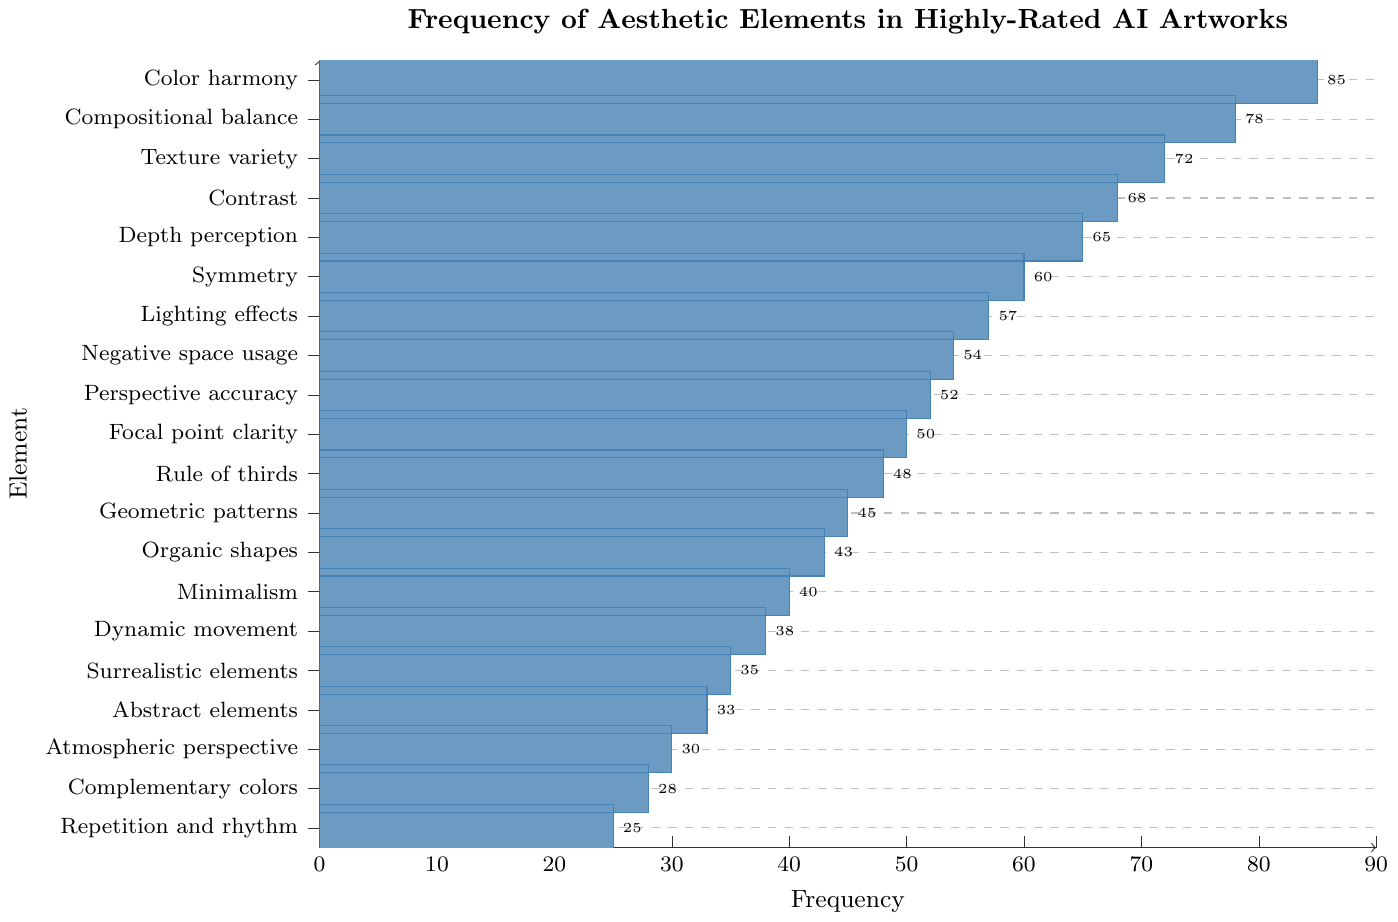What's the most frequently used aesthetic element in highly-rated AI artworks? The most frequent element can be identified by looking at the bar with the highest value in the chart. The highest bar represents "Color harmony" with a frequency of 85.
Answer: Color harmony Which aesthetic element is used the least frequently in highly-rated AI artworks? The least frequent element can be found by identifying the shortest bar. The shortest bar represents "Repetition and rhythm" with a frequency of 25.
Answer: Repetition and rhythm How much more frequently is "Depth perception" used compared to "Complimentary colors"? Find the frequencies for "Depth perception" (65) and "Complimentary colors" (28). Subtract the frequency of "Complimentary colors" from that of "Depth perception": 65 - 28 = 37.
Answer: 37 What is the combined frequency of "Lighting effects" and "Symmetry"? Identify the frequencies for "Lighting effects" (57) and "Symmetry" (60), then add them together: 57 + 60 = 117.
Answer: 117 What is the average frequency of the top 5 most frequently used aesthetic elements? Sum the frequencies of the top 5 elements: Color harmony (85), Compositional balance (78), Texture variety (72), Contrast (68), Depth perception (65). Total = 85 + 78 + 72 + 68 + 65 = 368. Divide by 5: 368 / 5 = 73.6.
Answer: 73.6 Which has a higher frequency: "Minimalism" or "Dynamic movement"? Compare the frequencies of "Minimalism" (40) and "Dynamic movement" (38). "Minimalism" has a higher frequency.
Answer: Minimalism How does the frequency of "Organic shapes" compare to "Abstract elements"? The frequency of "Organic shapes" is 43, while "Abstract elements" is 33. "Organic shapes" has a higher frequency.
Answer: Organic shapes What is the difference in frequency between “Geometric patterns” and “Rule of thirds”? Find the frequencies of "Geometric patterns" (45) and "Rule of thirds" (48). Subtract the smaller frequency from the larger: 48 - 45 = 3.
Answer: 3 What is the frequency range of the aesthetic elements? The frequency range is found by subtracting the smallest frequency (25 for Repetition and rhythm) from the largest frequency (85 for Color harmony): 85 - 25 = 60.
Answer: 60 Which aesthetic element frequencies fall within the range of 50 to 60, inclusive? Identify the bars with frequencies from 50 to 60: "Focal point clarity" (50), "Perspective accuracy" (52), "Negative space usage" (54), "Lighting effects" (57), "Symmetry" (60).
Answer: Focal point clarity, Perspective accuracy, Negative space usage, Lighting effects, Symmetry 